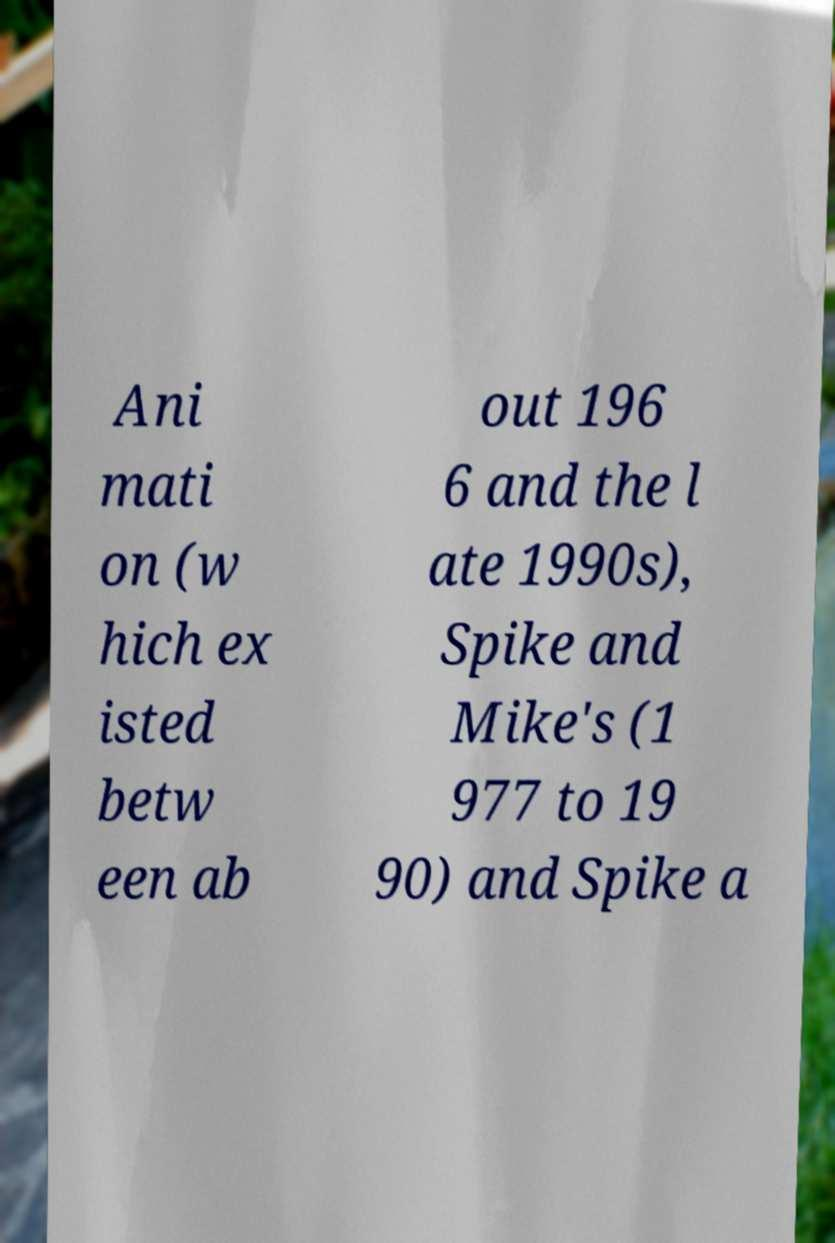There's text embedded in this image that I need extracted. Can you transcribe it verbatim? Ani mati on (w hich ex isted betw een ab out 196 6 and the l ate 1990s), Spike and Mike's (1 977 to 19 90) and Spike a 